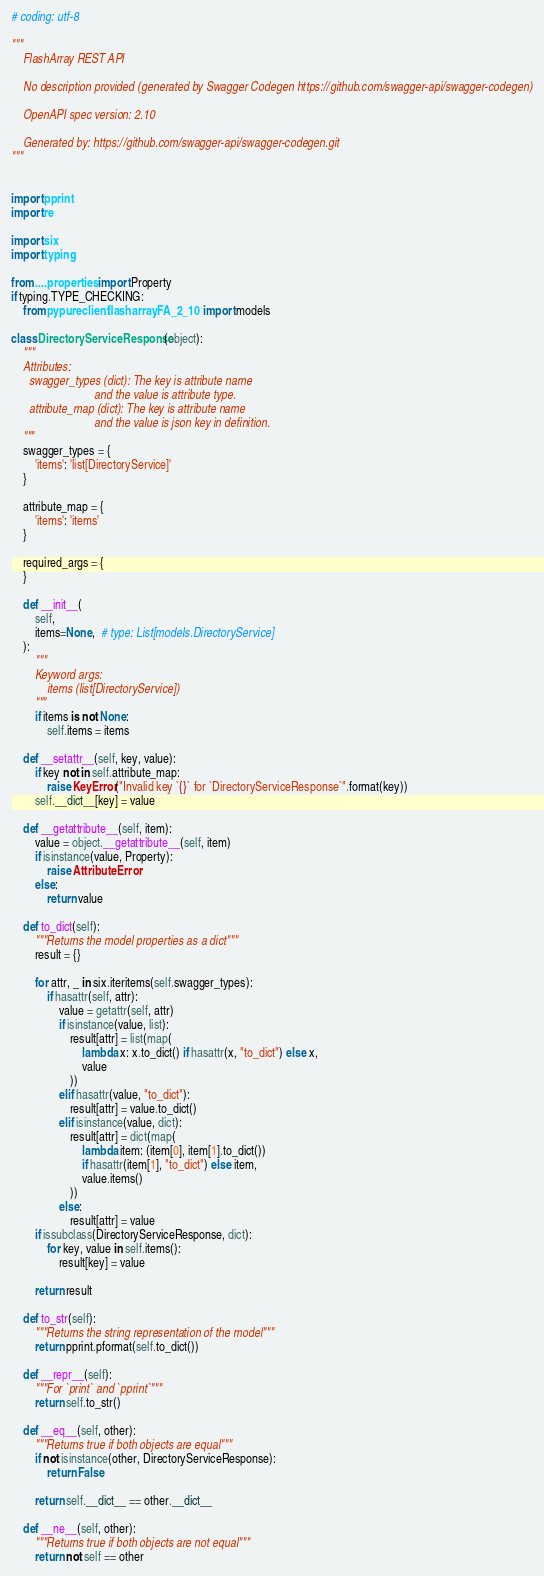Convert code to text. <code><loc_0><loc_0><loc_500><loc_500><_Python_># coding: utf-8

"""
    FlashArray REST API

    No description provided (generated by Swagger Codegen https://github.com/swagger-api/swagger-codegen)

    OpenAPI spec version: 2.10
    
    Generated by: https://github.com/swagger-api/swagger-codegen.git
"""


import pprint
import re

import six
import typing

from ....properties import Property
if typing.TYPE_CHECKING:
    from pypureclient.flasharray.FA_2_10 import models

class DirectoryServiceResponse(object):
    """
    Attributes:
      swagger_types (dict): The key is attribute name
                            and the value is attribute type.
      attribute_map (dict): The key is attribute name
                            and the value is json key in definition.
    """
    swagger_types = {
        'items': 'list[DirectoryService]'
    }

    attribute_map = {
        'items': 'items'
    }

    required_args = {
    }

    def __init__(
        self,
        items=None,  # type: List[models.DirectoryService]
    ):
        """
        Keyword args:
            items (list[DirectoryService])
        """
        if items is not None:
            self.items = items

    def __setattr__(self, key, value):
        if key not in self.attribute_map:
            raise KeyError("Invalid key `{}` for `DirectoryServiceResponse`".format(key))
        self.__dict__[key] = value

    def __getattribute__(self, item):
        value = object.__getattribute__(self, item)
        if isinstance(value, Property):
            raise AttributeError
        else:
            return value

    def to_dict(self):
        """Returns the model properties as a dict"""
        result = {}

        for attr, _ in six.iteritems(self.swagger_types):
            if hasattr(self, attr):
                value = getattr(self, attr)
                if isinstance(value, list):
                    result[attr] = list(map(
                        lambda x: x.to_dict() if hasattr(x, "to_dict") else x,
                        value
                    ))
                elif hasattr(value, "to_dict"):
                    result[attr] = value.to_dict()
                elif isinstance(value, dict):
                    result[attr] = dict(map(
                        lambda item: (item[0], item[1].to_dict())
                        if hasattr(item[1], "to_dict") else item,
                        value.items()
                    ))
                else:
                    result[attr] = value
        if issubclass(DirectoryServiceResponse, dict):
            for key, value in self.items():
                result[key] = value

        return result

    def to_str(self):
        """Returns the string representation of the model"""
        return pprint.pformat(self.to_dict())

    def __repr__(self):
        """For `print` and `pprint`"""
        return self.to_str()

    def __eq__(self, other):
        """Returns true if both objects are equal"""
        if not isinstance(other, DirectoryServiceResponse):
            return False

        return self.__dict__ == other.__dict__

    def __ne__(self, other):
        """Returns true if both objects are not equal"""
        return not self == other
</code> 